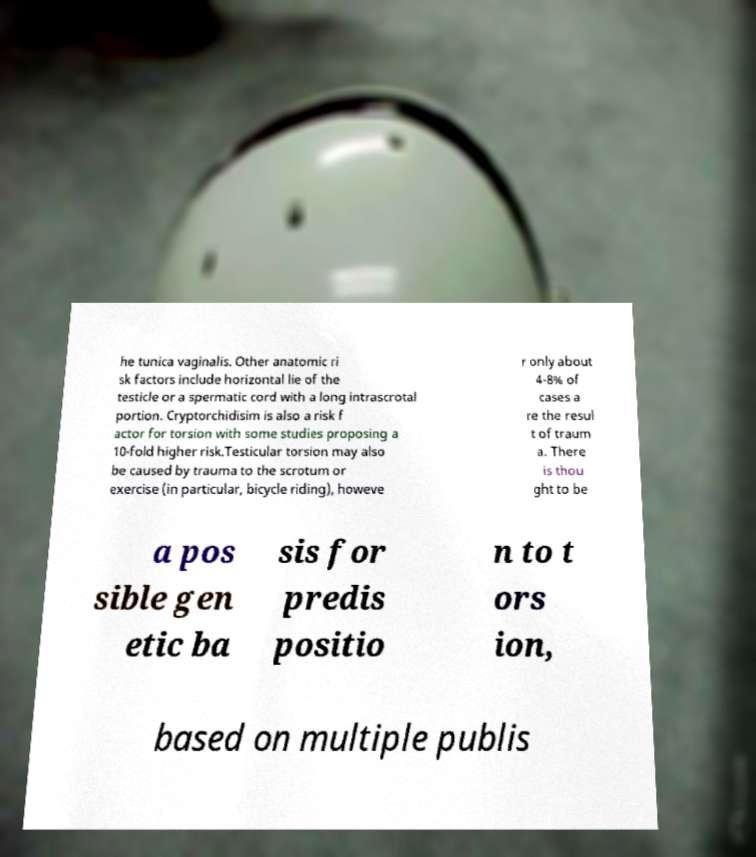What messages or text are displayed in this image? I need them in a readable, typed format. he tunica vaginalis. Other anatomic ri sk factors include horizontal lie of the testicle or a spermatic cord with a long intrascrotal portion. Cryptorchidisim is also a risk f actor for torsion with some studies proposing a 10-fold higher risk.Testicular torsion may also be caused by trauma to the scrotum or exercise (in particular, bicycle riding), howeve r only about 4-8% of cases a re the resul t of traum a. There is thou ght to be a pos sible gen etic ba sis for predis positio n to t ors ion, based on multiple publis 